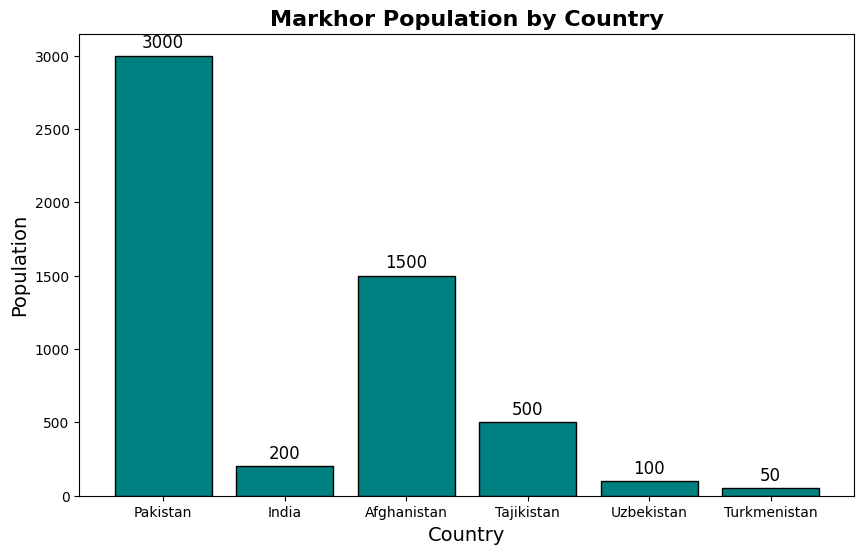What is the total population of Markhors in all the countries combined? Sum up the populations of each country: 3000 (Pakistan) + 200 (India) + 1500 (Afghanistan) + 500 (Tajikistan) + 100 (Uzbekistan) + 50 (Turkmenistan). This gives 3000 + 200 + 1500 + 500 + 100 + 50 = 5350.
Answer: 5350 Which country has the highest Markhor population? Look for the tallest bar in the chart. The tallest bar corresponds to Pakistan, with a population of 3000.
Answer: Pakistan What percentage of the total Markhor population is found in Pakistan? First, find the total Markhor population, which is 5350. The population in Pakistan is 3000. To find the percentage: (3000 / 5350) * 100 = 56.07%.
Answer: 56.07% What is the difference in the Markhor population between India and Afghanistan? Afghanistan has 1500 Markhors, and India has 200. Subtract the Indian population from the Afghan population: 1500 - 200 = 1300.
Answer: 1300 Which country has the smallest Markhor population, and what is it? Look for the shortest bar in the chart. The shortest bar corresponds to Turkmenistan, with a population of 50.
Answer: Turkmenistan, 50 How many countries have a Markhor population greater than 500? Count the countries with populations exceeding 500: Pakistan (3000), and Afghanistan (1500). This gives a count of 2.
Answer: 2 What is the average Markhor population among all the countries? Sum the populations: 5350. Divide by the number of countries (6): 5350 / 6 ≈ 891.67.
Answer: 891.67 What is the combined Markhor population of the three countries with the lowest populations? The three countries with the lowest populations are Turkmenistan (50), Uzbekistan (100), and India (200). Sum these populations: 50 + 100 + 200 = 350.
Answer: 350 Which country has a Markhor population closest to the average population? First, calculate the average population: 891.67. Compare each country's population to this average. Tajikistan, with a population of 500, is the closest to 891.67.
Answer: Tajikistan Among the countries listed, how many have a Markhor population of fewer than 1000? Count the countries with populations less than 1000. These are India (200), Afghanistan (1500), Tajikistan (500), Uzbekistan (100), and Turkmenistan (50). This gives a count of 4.
Answer: 4 